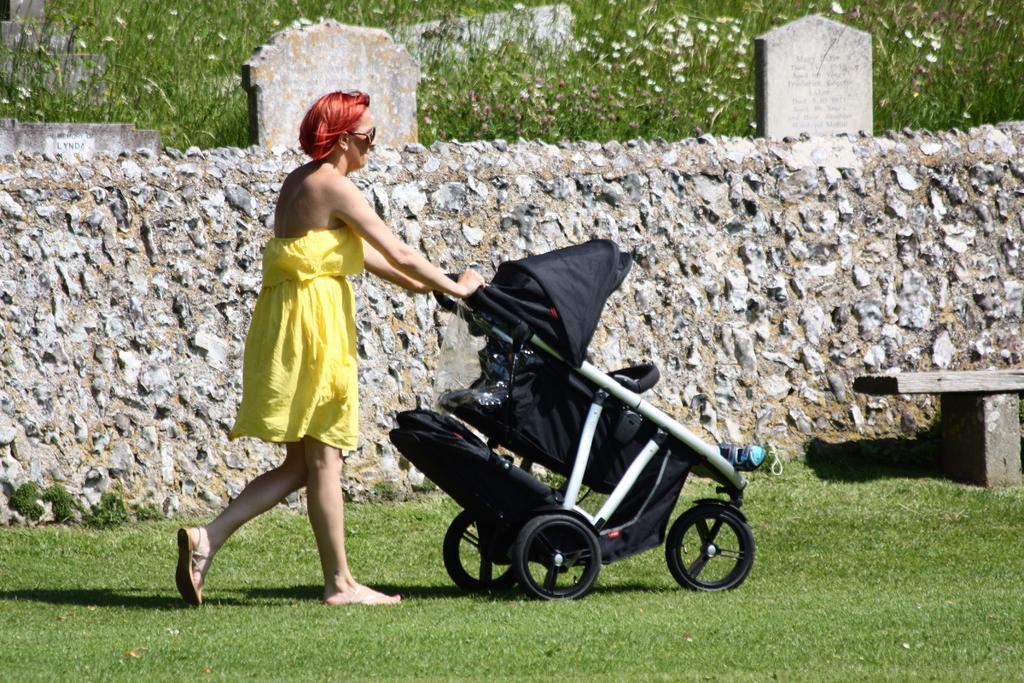In one or two sentences, can you explain what this image depicts? In the center of the image there is a lady walking holding a baby trolley. At the bottom of the image there is grass. In the background of the image there is a stone wall. There are plants. To the right side of the image there is a bench. 